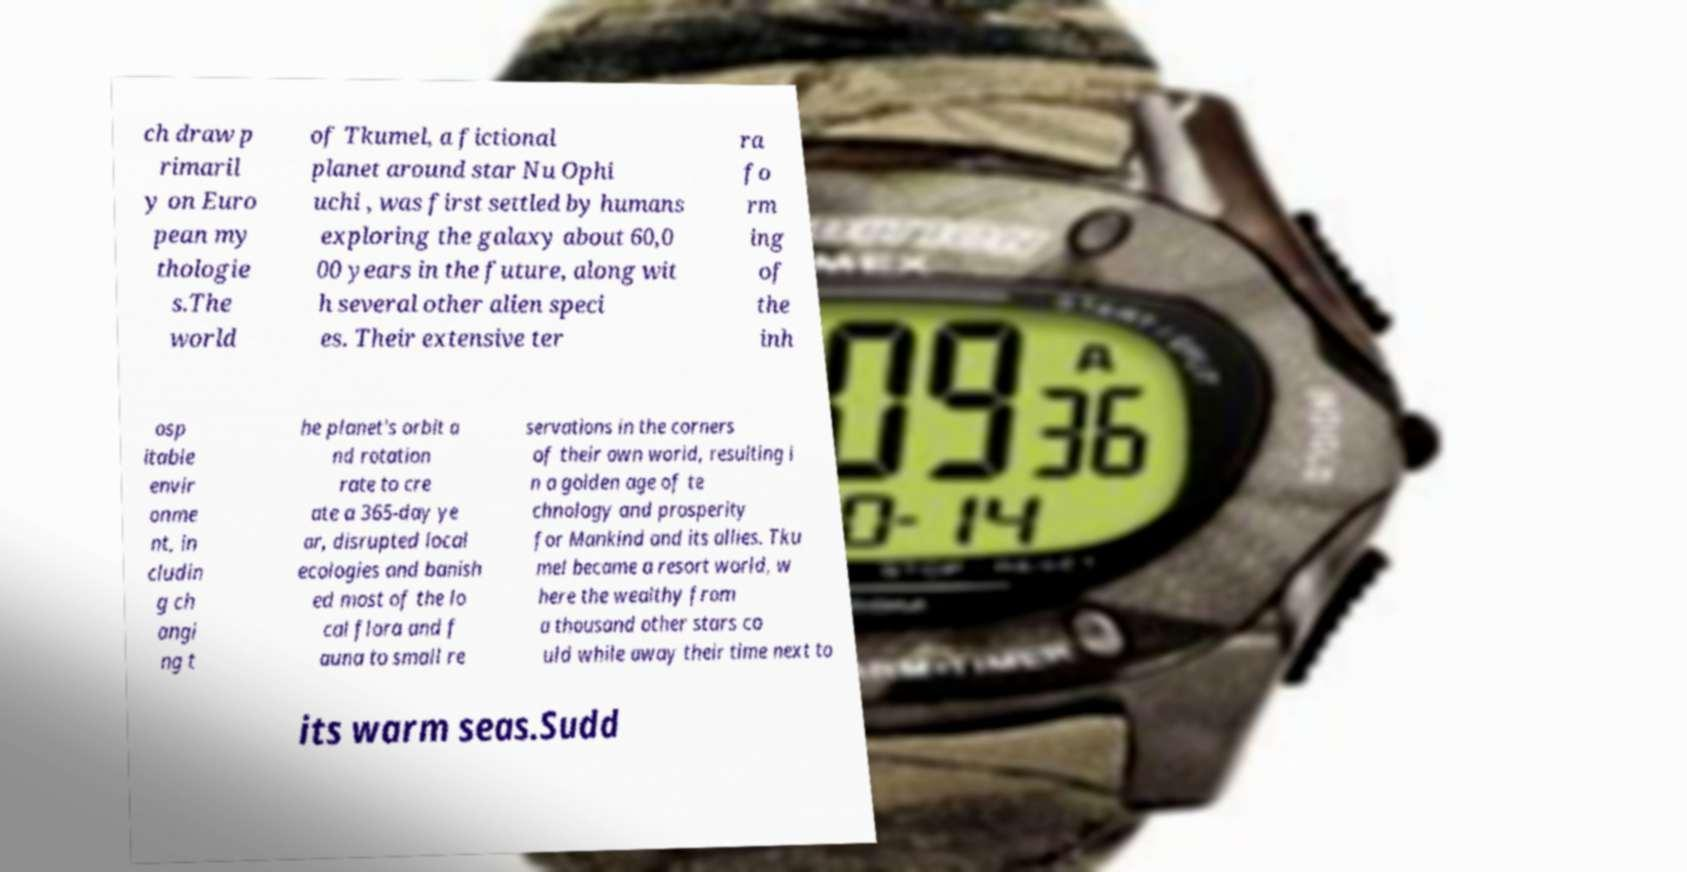I need the written content from this picture converted into text. Can you do that? ch draw p rimaril y on Euro pean my thologie s.The world of Tkumel, a fictional planet around star Nu Ophi uchi , was first settled by humans exploring the galaxy about 60,0 00 years in the future, along wit h several other alien speci es. Their extensive ter ra fo rm ing of the inh osp itable envir onme nt, in cludin g ch angi ng t he planet's orbit a nd rotation rate to cre ate a 365-day ye ar, disrupted local ecologies and banish ed most of the lo cal flora and f auna to small re servations in the corners of their own world, resulting i n a golden age of te chnology and prosperity for Mankind and its allies. Tku mel became a resort world, w here the wealthy from a thousand other stars co uld while away their time next to its warm seas.Sudd 